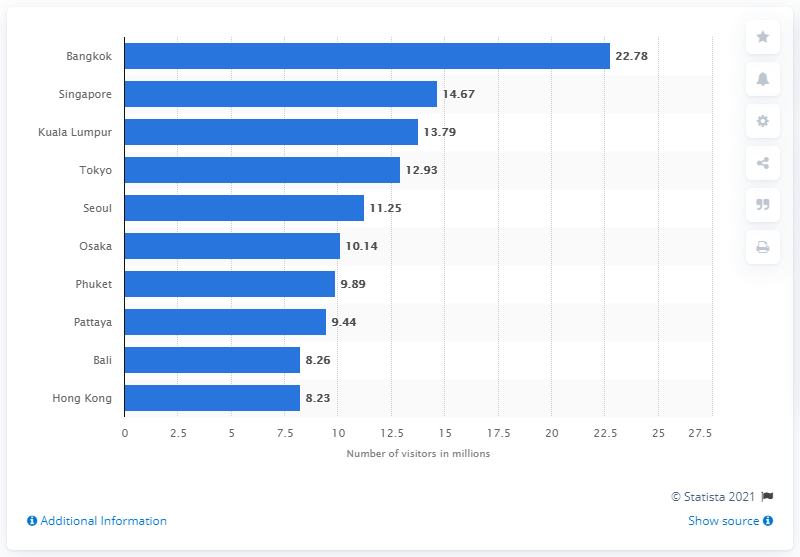How many international overnight visitors visited Bangkok in 2018? In 2018, Bangkok welcomed approximately 22.78 million international overnight visitors, making it one of the world's most visited cities. 